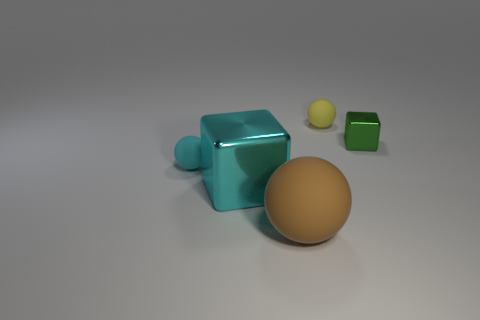How many matte balls are both right of the cyan metal object and behind the big matte ball?
Make the answer very short. 1. The cube that is in front of the tiny matte sphere in front of the tiny ball behind the small green metal cube is what color?
Give a very brief answer. Cyan. What number of other objects are the same shape as the green metallic thing?
Your answer should be compact. 1. There is a metal thing in front of the small green thing; is there a cyan matte thing right of it?
Provide a succinct answer. No. How many metallic objects are tiny cyan cylinders or large cyan cubes?
Make the answer very short. 1. What material is the object that is both in front of the tiny cyan rubber thing and to the left of the big rubber sphere?
Your answer should be very brief. Metal. Is there a brown sphere behind the metal block to the left of the matte sphere that is in front of the large cyan object?
Your answer should be compact. No. Is there anything else that is made of the same material as the small green cube?
Offer a very short reply. Yes. What is the shape of the big thing that is the same material as the cyan ball?
Your answer should be very brief. Sphere. Is the number of big brown things that are in front of the large ball less than the number of small rubber things to the right of the cyan matte object?
Ensure brevity in your answer.  Yes. 